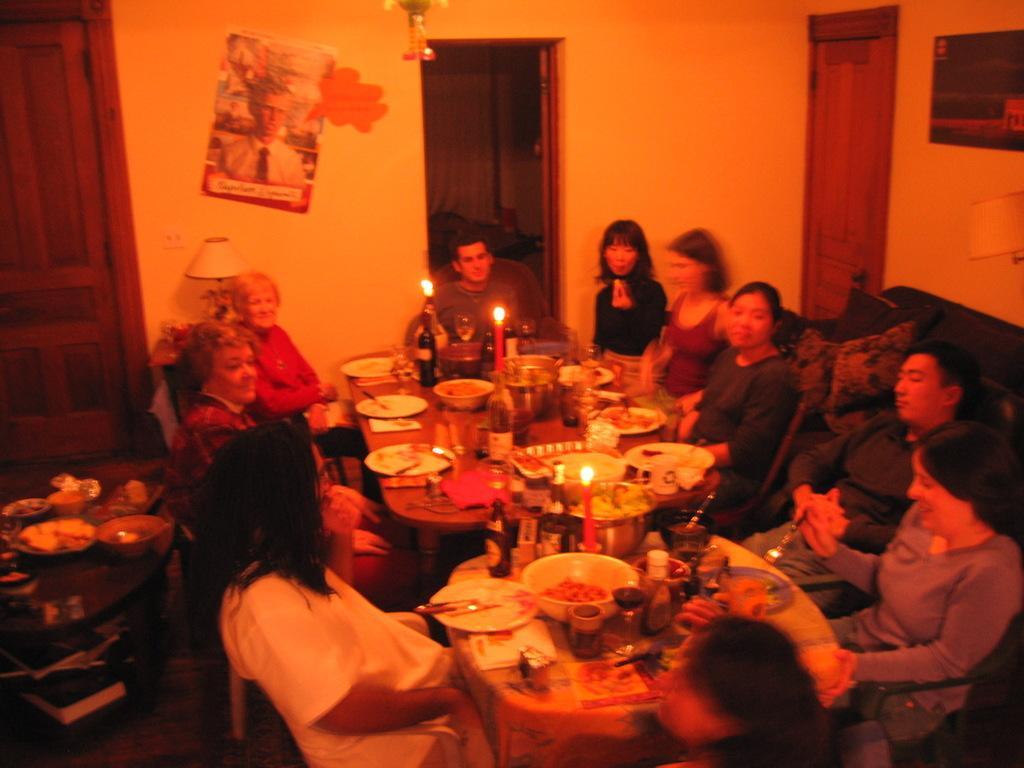How would you summarize this image in a sentence or two? The picture is inside a room. There are many people sitting on chair. There are tables in the room. On the tables there are foods, bottles,cup,candle. There is a sofa on the right side. Beside it there is a door. In the background there is a door and a poster. On the top left there is another door. 